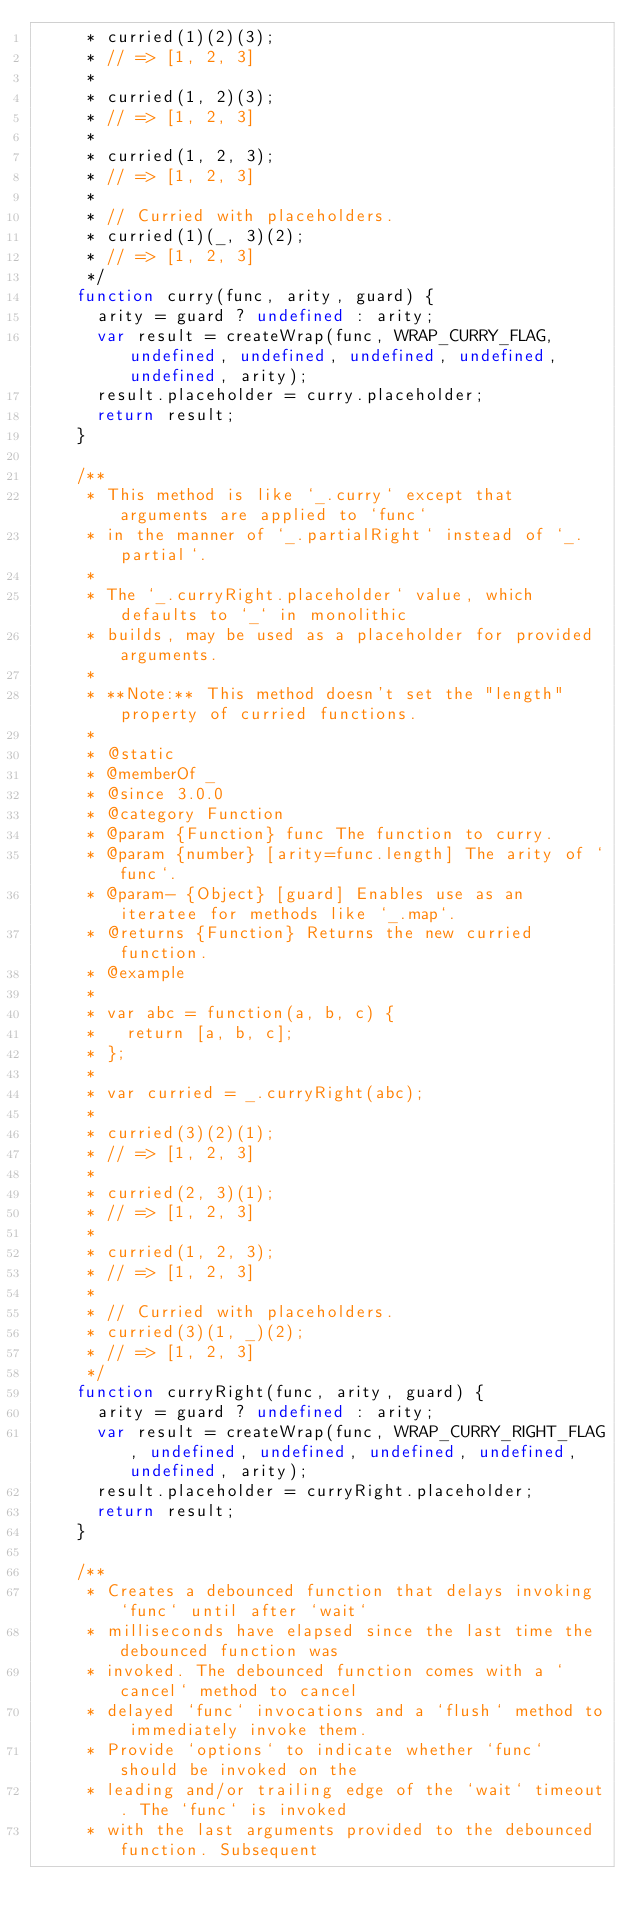<code> <loc_0><loc_0><loc_500><loc_500><_JavaScript_>     * curried(1)(2)(3);
     * // => [1, 2, 3]
     *
     * curried(1, 2)(3);
     * // => [1, 2, 3]
     *
     * curried(1, 2, 3);
     * // => [1, 2, 3]
     *
     * // Curried with placeholders.
     * curried(1)(_, 3)(2);
     * // => [1, 2, 3]
     */
    function curry(func, arity, guard) {
      arity = guard ? undefined : arity;
      var result = createWrap(func, WRAP_CURRY_FLAG, undefined, undefined, undefined, undefined, undefined, arity);
      result.placeholder = curry.placeholder;
      return result;
    }

    /**
     * This method is like `_.curry` except that arguments are applied to `func`
     * in the manner of `_.partialRight` instead of `_.partial`.
     *
     * The `_.curryRight.placeholder` value, which defaults to `_` in monolithic
     * builds, may be used as a placeholder for provided arguments.
     *
     * **Note:** This method doesn't set the "length" property of curried functions.
     *
     * @static
     * @memberOf _
     * @since 3.0.0
     * @category Function
     * @param {Function} func The function to curry.
     * @param {number} [arity=func.length] The arity of `func`.
     * @param- {Object} [guard] Enables use as an iteratee for methods like `_.map`.
     * @returns {Function} Returns the new curried function.
     * @example
     *
     * var abc = function(a, b, c) {
     *   return [a, b, c];
     * };
     *
     * var curried = _.curryRight(abc);
     *
     * curried(3)(2)(1);
     * // => [1, 2, 3]
     *
     * curried(2, 3)(1);
     * // => [1, 2, 3]
     *
     * curried(1, 2, 3);
     * // => [1, 2, 3]
     *
     * // Curried with placeholders.
     * curried(3)(1, _)(2);
     * // => [1, 2, 3]
     */
    function curryRight(func, arity, guard) {
      arity = guard ? undefined : arity;
      var result = createWrap(func, WRAP_CURRY_RIGHT_FLAG, undefined, undefined, undefined, undefined, undefined, arity);
      result.placeholder = curryRight.placeholder;
      return result;
    }

    /**
     * Creates a debounced function that delays invoking `func` until after `wait`
     * milliseconds have elapsed since the last time the debounced function was
     * invoked. The debounced function comes with a `cancel` method to cancel
     * delayed `func` invocations and a `flush` method to immediately invoke them.
     * Provide `options` to indicate whether `func` should be invoked on the
     * leading and/or trailing edge of the `wait` timeout. The `func` is invoked
     * with the last arguments provided to the debounced function. Subsequent</code> 